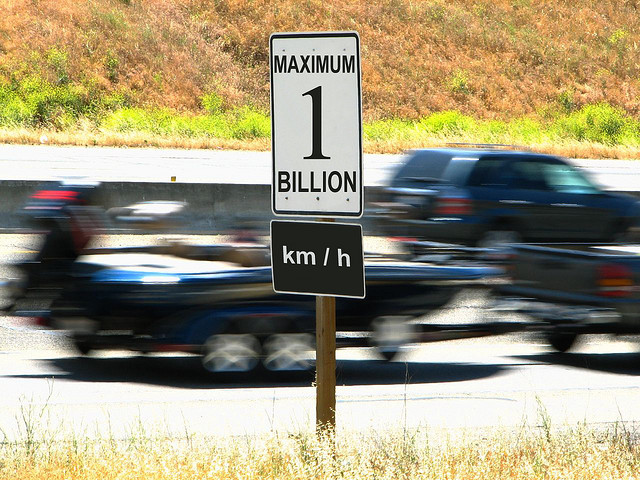Is this road sign likely to be an official traffic sign, and why or why not? This road sign is most likely not an official traffic sign. Official speed limits are set within realistic and safe driving ranges, and a limit of '1 BILLION km/h' far exceeds any limits you would find on public roads. This appears to be a humorous or artistic installation meant to provoke thought or amusement rather than regulate traffic. 